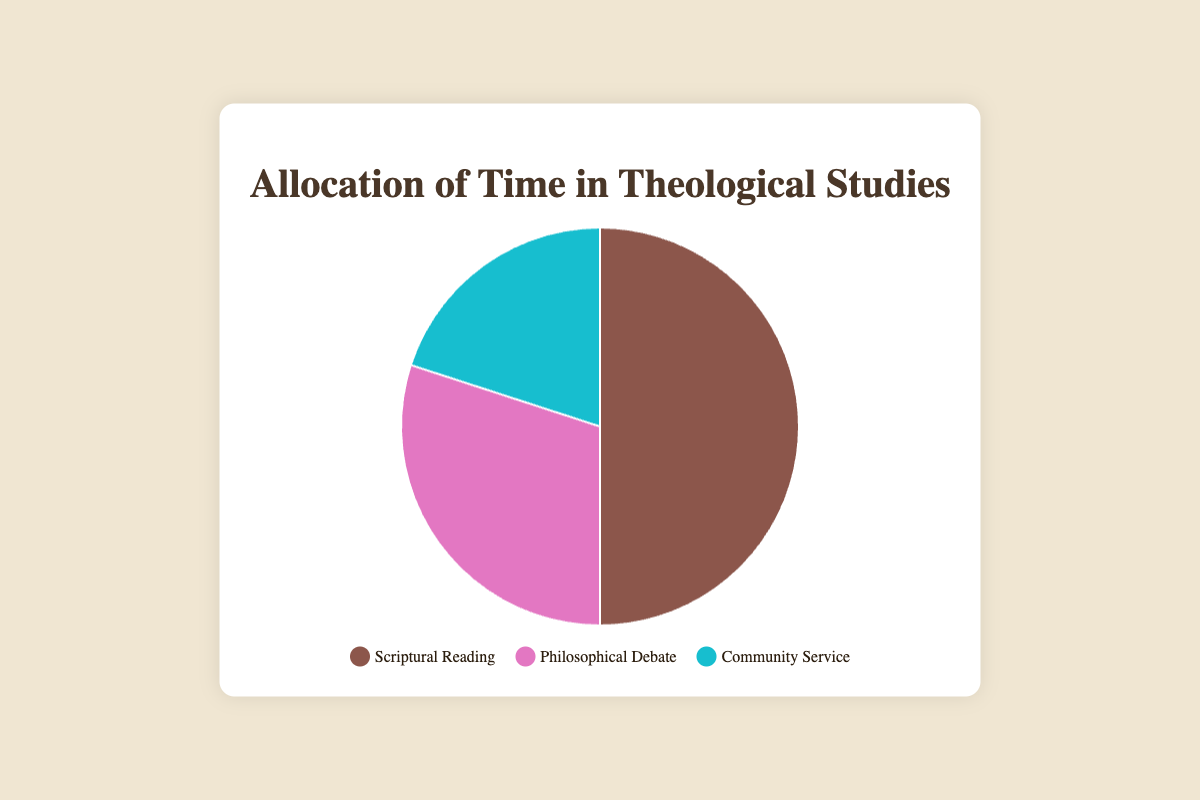What percentage of time is allocated to Philosophical Debate? By observing the pie chart, we can see the segment labeled 'Philosophical Debate' which indicates the percentage.
Answer: 30 How much more time is allocated to Scriptural Reading compared to Community Service? The time allocated to Scriptural Reading is 50%, and for Community Service, it is 20%. The difference is calculated as 50% - 20%.
Answer: 30% What is the combined percentage of time spent on Philosophical Debate and Community Service? Adding the percentages of Philosophical Debate (30%) and Community Service (20%) gives us the combined percentage.
Answer: 50% Which category has the smallest allocation of time? By comparing the percentage values of all categories, Community Service has the smallest allocation at 20%.
Answer: Community Service What is the dominant activity in terms of time allocation? The segment with the largest percentage represents the dominant activity. Scriptural Reading is allocated 50%, which is the highest among the three categories.
Answer: Scriptural Reading Which category is represented by the color blue? By checking the legend, the blue color corresponds to the Community Service category.
Answer: Community Service Is the time allocated to Philosophical Debate greater than 25%? By observing the pie chart, we see the Philosophical Debate is allocated 30%, which is indeed greater than 25%.
Answer: Yes What percentage of time is allocated to activities involving individuals like Thomas Aquinas? The Philosophical Debate category, which involves individuals like Thomas Aquinas, is allocated 30% of the time.
Answer: 30% Calculate the average percentage of time allocated to Scriptural Reading, Philosophical Debate, and Community Service. Sum the percentages (50% + 30% + 20%) and divide by 3 to find the average: (50 + 30 + 20) / 3 = 33.33%.
Answer: 33.33% Which activity has more time allocated: Community Service or Philosophical Debate? Comparing the percentages, Community Service has 20%, and Philosophical Debate has 30%. Philosophical Debate has more time allocated.
Answer: Philosophical Debate 